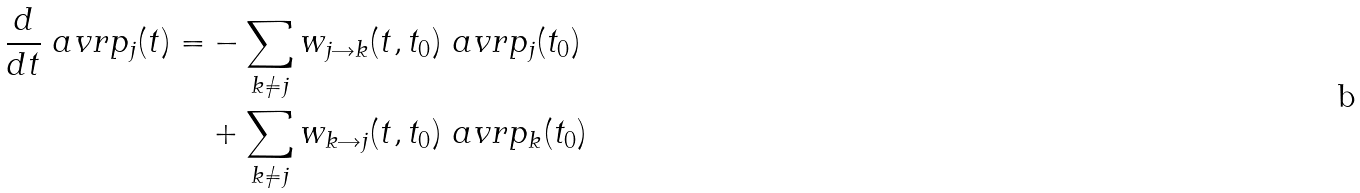<formula> <loc_0><loc_0><loc_500><loc_500>\frac { d } { d t } \ a v r { p _ { j } ( t ) } = & - \sum _ { k \not = j } w _ { j \rightarrow k } ( t , t _ { 0 } ) \ a v r { p _ { j } ( t _ { 0 } ) } \\ & + \sum _ { k \not = j } w _ { k \rightarrow j } ( t , t _ { 0 } ) \ a v r { p _ { k } ( t _ { 0 } ) }</formula> 